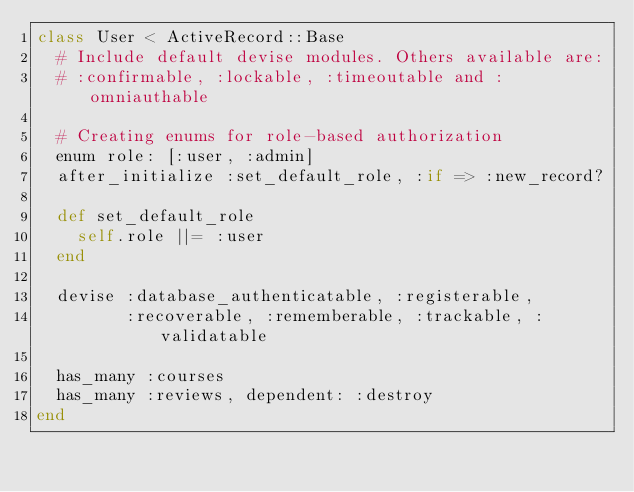<code> <loc_0><loc_0><loc_500><loc_500><_Ruby_>class User < ActiveRecord::Base
  # Include default devise modules. Others available are:
  # :confirmable, :lockable, :timeoutable and :omniauthable

  # Creating enums for role-based authorization
  enum role: [:user, :admin]
  after_initialize :set_default_role, :if => :new_record?
 
  def set_default_role
    self.role ||= :user
  end

  devise :database_authenticatable, :registerable,
         :recoverable, :rememberable, :trackable, :validatable

  has_many :courses
  has_many :reviews, dependent: :destroy
end
</code> 